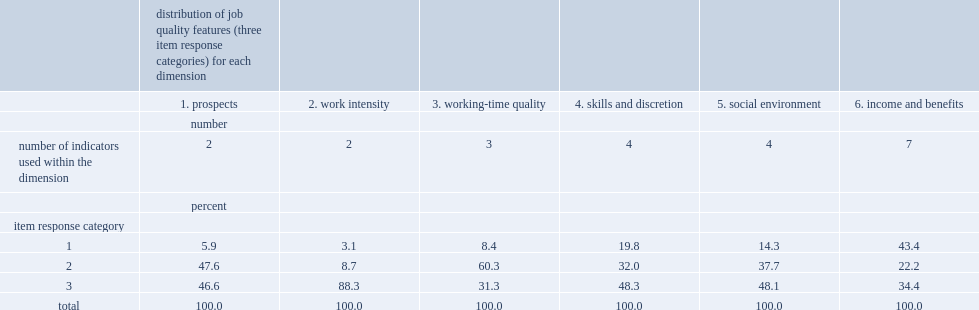Can you give me this table as a dict? {'header': ['', 'distribution of job quality features (three item response categories) for each dimension', '', '', '', '', ''], 'rows': [['', '1. prospects', '2. work intensity', '3. working-time quality', '4. skills and discretion', '5. social environment', '6. income and benefits'], ['', 'number', '', '', '', '', ''], ['number of indicators used within the dimension', '2', '2', '3', '4', '4', '7'], ['', 'percent', '', '', '', '', ''], ['item response category', '', '', '', '', '', ''], ['1', '5.9', '3.1', '8.4', '19.8', '14.3', '43.4'], ['2', '47.6', '8.7', '60.3', '32.0', '37.7', '22.2'], ['3', '46.6', '88.3', '31.3', '48.3', '48.1', '34.4'], ['total', '100.0', '100.0', '100.0', '100.0', '100.0', '100.0']]} What was the percentage of those who said their jobs provided none or only one of the seven employment benefits included? 43.4. What was the percentage of workers reported being in the best category in work intensity dimension? 88.3. 